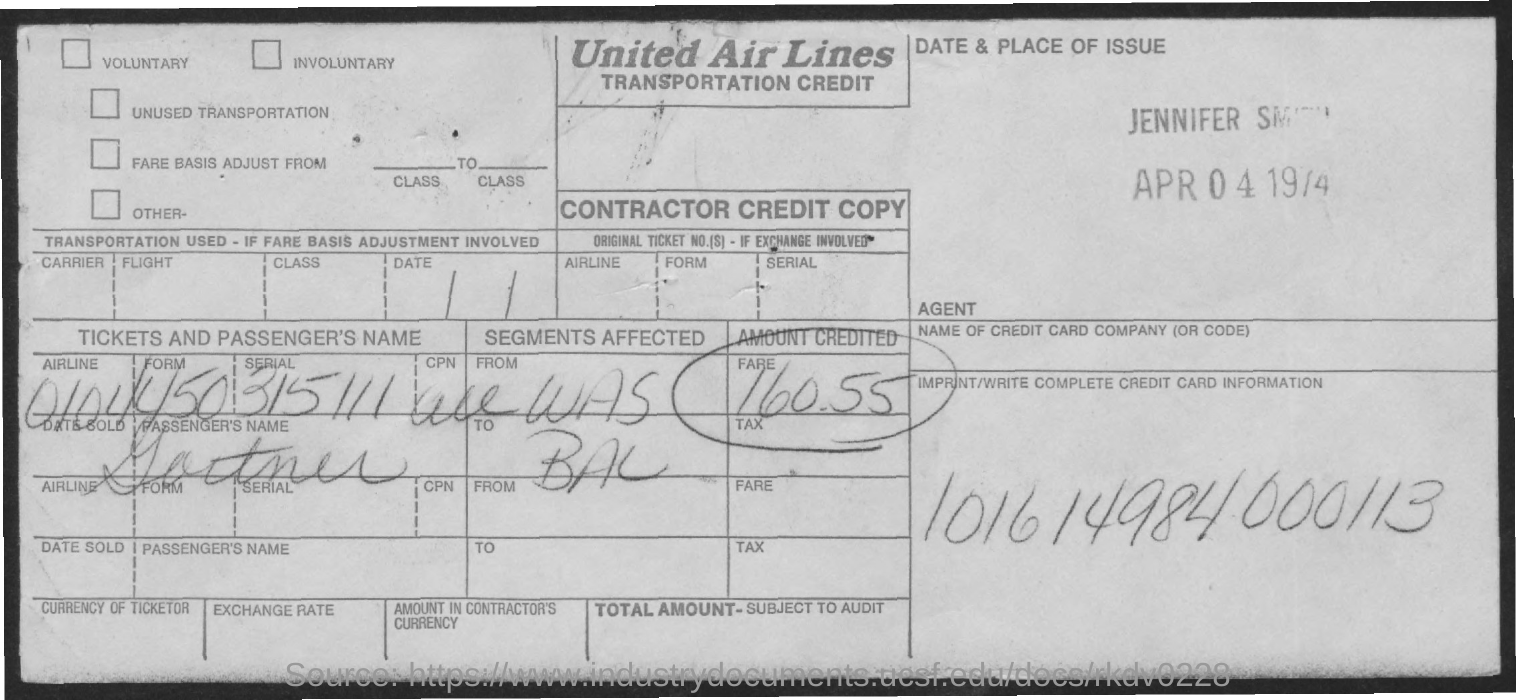Which Airline is mentioned in the form?
Give a very brief answer. United Air Lines. What is the amount credited (Fare) mentioned in the form?
Your answer should be compact. 160.55. What is the Credit Card information given in the form?
Ensure brevity in your answer.  101614984000113. 